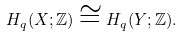Convert formula to latex. <formula><loc_0><loc_0><loc_500><loc_500>H _ { q } ( X ; \mathbb { Z } ) \cong H _ { q } ( Y ; \mathbb { Z } ) .</formula> 